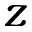Convert formula to latex. <formula><loc_0><loc_0><loc_500><loc_500>z</formula> 